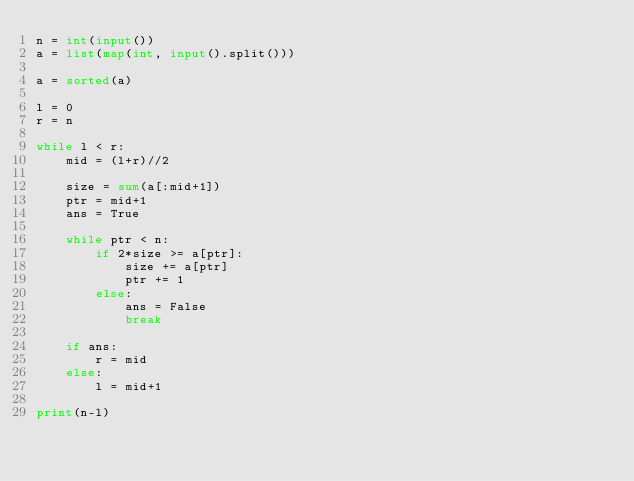Convert code to text. <code><loc_0><loc_0><loc_500><loc_500><_Python_>n = int(input())
a = list(map(int, input().split()))

a = sorted(a)

l = 0
r = n

while l < r:
    mid = (l+r)//2

    size = sum(a[:mid+1])
    ptr = mid+1
    ans = True

    while ptr < n:
        if 2*size >= a[ptr]:
            size += a[ptr]
            ptr += 1
        else:
            ans = False
            break

    if ans:
        r = mid
    else:
        l = mid+1

print(n-l)</code> 